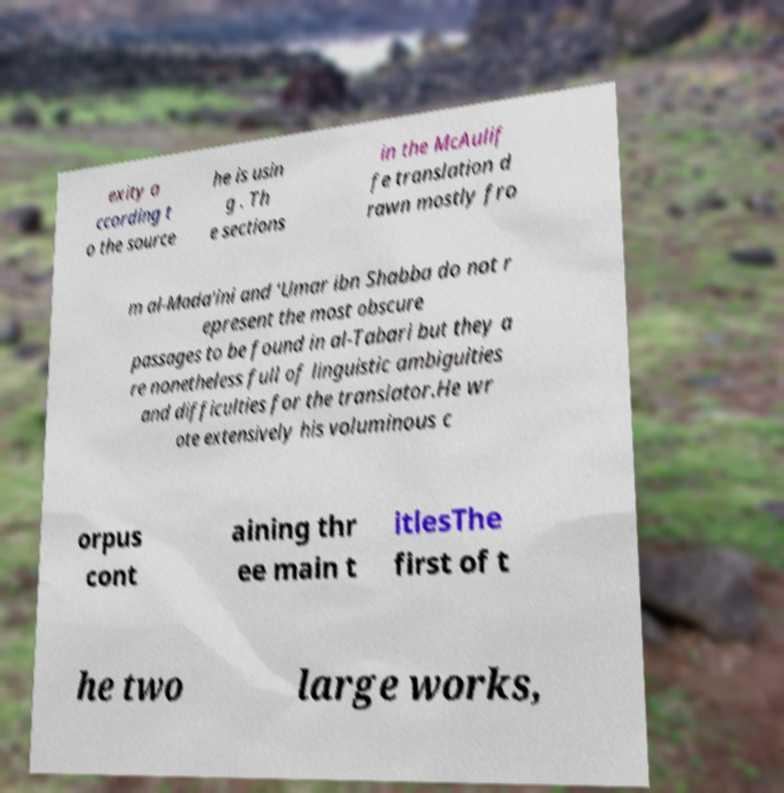Please read and relay the text visible in this image. What does it say? exity a ccording t o the source he is usin g . Th e sections in the McAulif fe translation d rawn mostly fro m al-Mada'ini and 'Umar ibn Shabba do not r epresent the most obscure passages to be found in al-Tabari but they a re nonetheless full of linguistic ambiguities and difficulties for the translator.He wr ote extensively his voluminous c orpus cont aining thr ee main t itlesThe first of t he two large works, 